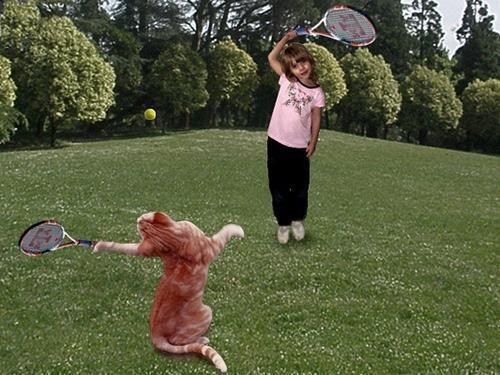How many humans are there?
Give a very brief answer. 1. 